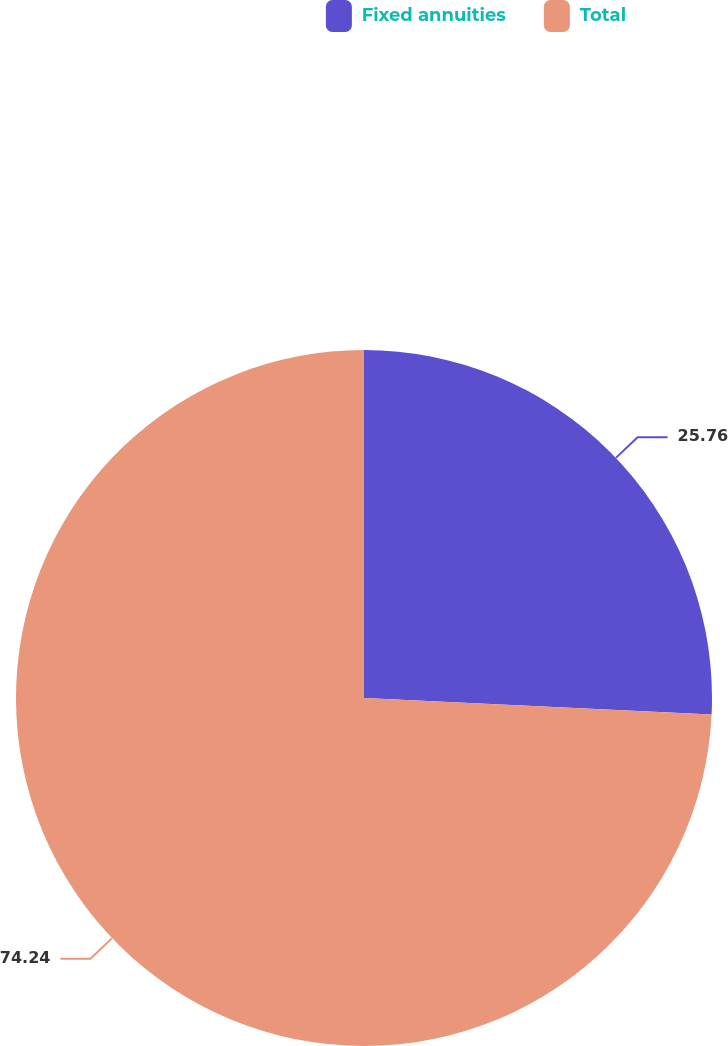Convert chart. <chart><loc_0><loc_0><loc_500><loc_500><pie_chart><fcel>Fixed annuities<fcel>Total<nl><fcel>25.76%<fcel>74.24%<nl></chart> 